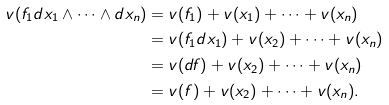<formula> <loc_0><loc_0><loc_500><loc_500>v ( f _ { 1 } d x _ { 1 } \wedge \cdots \wedge d x _ { n } ) & = v ( f _ { 1 } ) + v ( x _ { 1 } ) + \dots + v ( x _ { n } ) \\ & = v ( f _ { 1 } d x _ { 1 } ) + v ( x _ { 2 } ) + \dots + v ( x _ { n } ) \\ & = v ( d f ) + v ( x _ { 2 } ) + \dots + v ( x _ { n } ) \\ & = v ( f ) + v ( x _ { 2 } ) + \dots + v ( x _ { n } ) .</formula> 